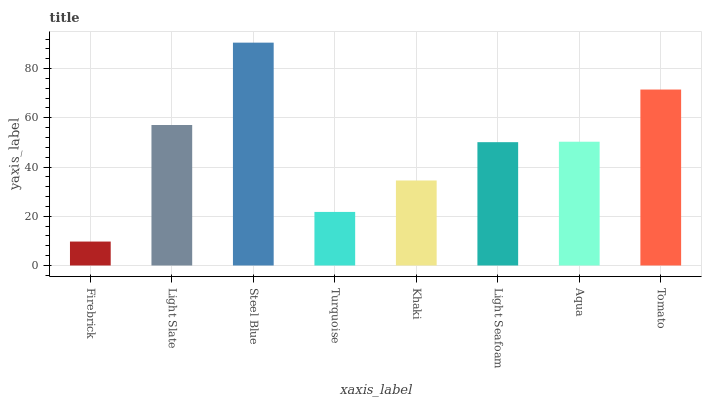Is Firebrick the minimum?
Answer yes or no. Yes. Is Steel Blue the maximum?
Answer yes or no. Yes. Is Light Slate the minimum?
Answer yes or no. No. Is Light Slate the maximum?
Answer yes or no. No. Is Light Slate greater than Firebrick?
Answer yes or no. Yes. Is Firebrick less than Light Slate?
Answer yes or no. Yes. Is Firebrick greater than Light Slate?
Answer yes or no. No. Is Light Slate less than Firebrick?
Answer yes or no. No. Is Aqua the high median?
Answer yes or no. Yes. Is Light Seafoam the low median?
Answer yes or no. Yes. Is Khaki the high median?
Answer yes or no. No. Is Turquoise the low median?
Answer yes or no. No. 